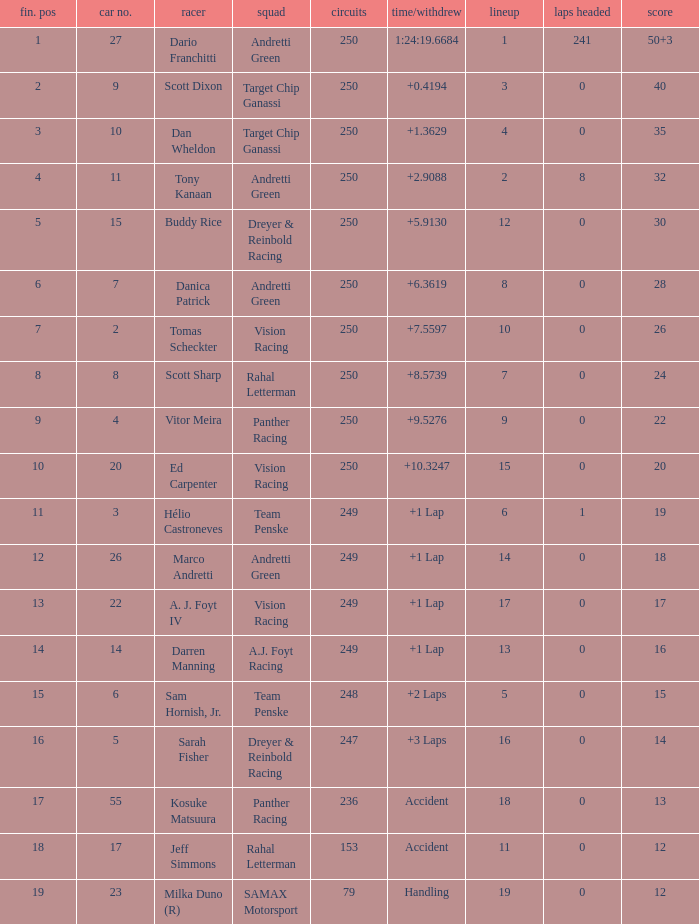Name the total number of cars for panther racing and grid of 9 1.0. 